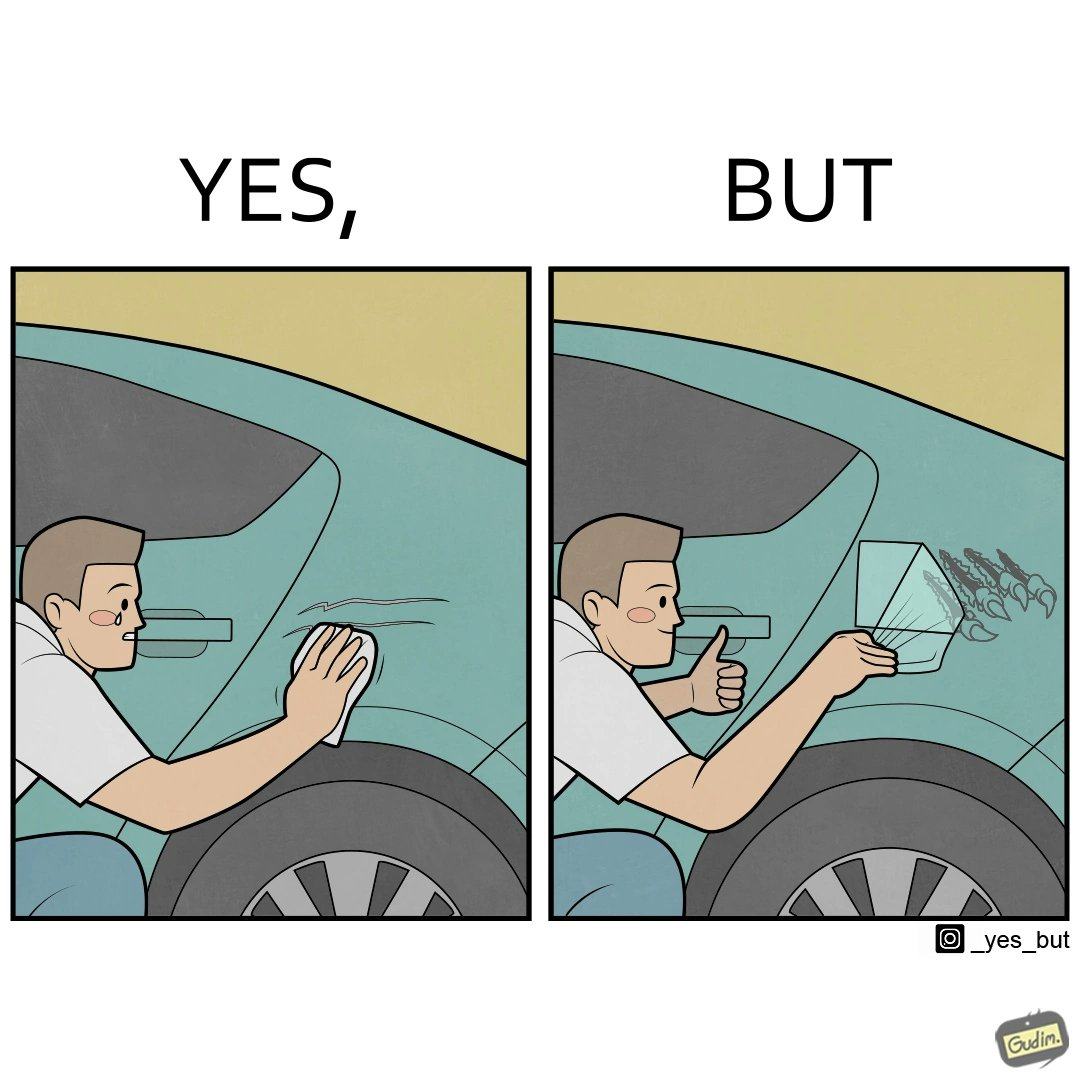Would you classify this image as satirical? Yes, this image is satirical. 